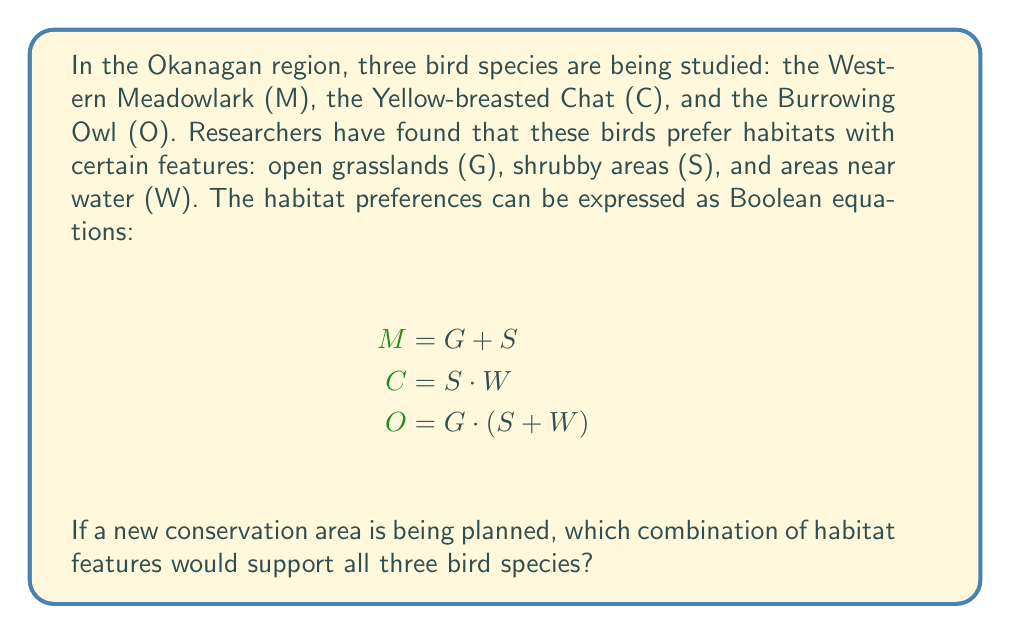Can you answer this question? Let's approach this step-by-step using Boolean algebra:

1) We need to find a combination that satisfies all three equations simultaneously. This means we're looking for the Boolean AND (•) of all three equations:

   $$(G + S) • (S • W) • (G • (S + W))$$

2) Let's simplify from left to right:
   
   First, distribute $(G + S)$ over $(S • W)$:
   $$((G • S • W) + (S • S • W)) • (G • (S + W))$$
   
   Simplify $S • S = S$:
   $$((G • S • W) + (S • W)) • (G • (S + W))$$

3) Now, distribute $G • (S + W)$:
   $$((G • S • W) + (S • W)) • (G • S + G • W)$$

4) Apply the distributive property again:
   $$(G • S • W • G • S) + (G • S • W • G • W) + (S • W • G • S) + (S • W • G • W)$$

5) Simplify redundant terms ($G • G = G$, $S • S = S$, $W • W = W$):
   $$(G • S • W) + (G • S • W) + (G • S • W) + (G • S • W)$$

6) Multiple occurrences of the same term in Boolean OR (+) can be reduced to a single occurrence:
   $$G • S • W$$

This final expression represents the combination of habitat features that would support all three bird species.
Answer: $G • S • W$ 